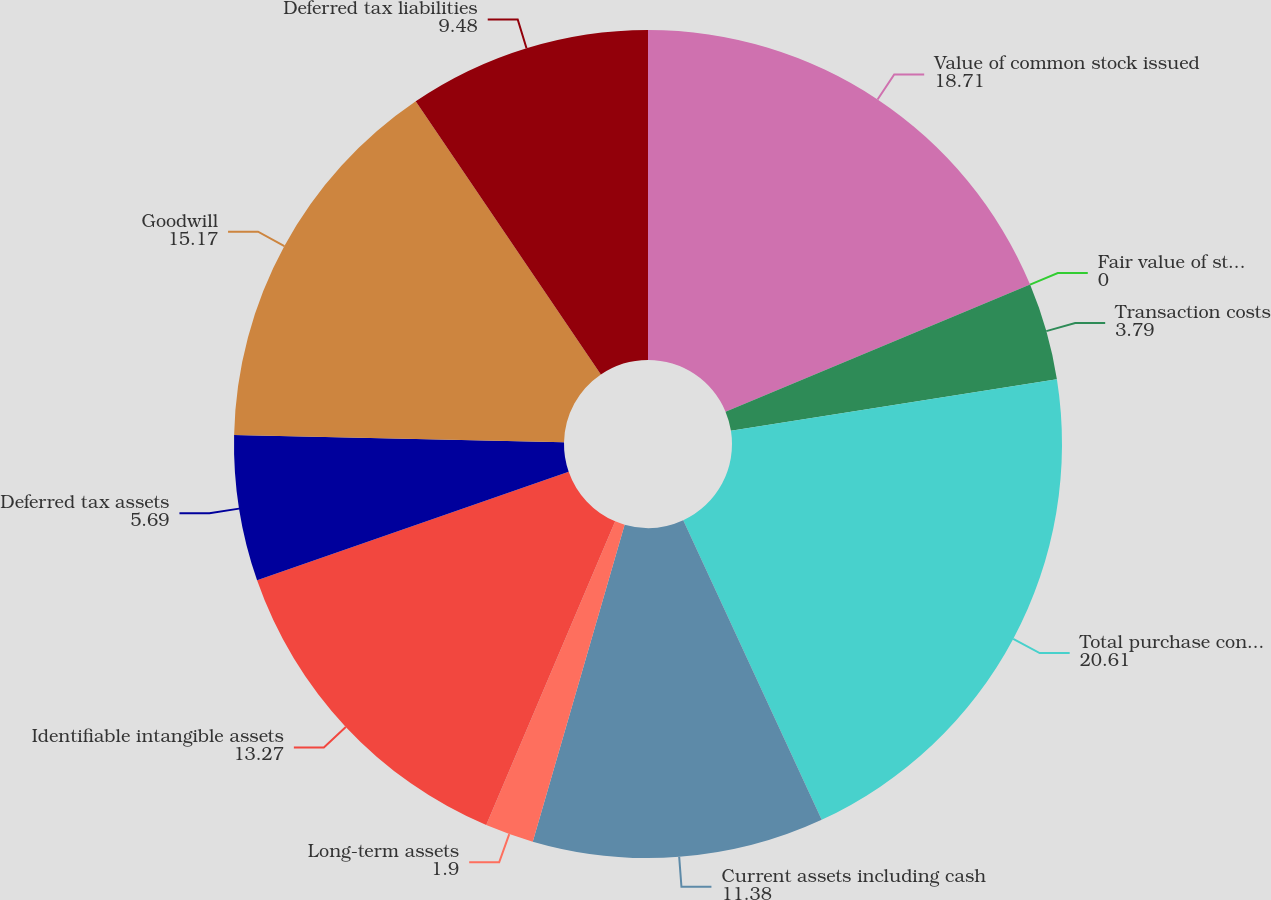Convert chart to OTSL. <chart><loc_0><loc_0><loc_500><loc_500><pie_chart><fcel>Value of common stock issued<fcel>Fair value of stock options<fcel>Transaction costs<fcel>Total purchase consideration<fcel>Current assets including cash<fcel>Long-term assets<fcel>Identifiable intangible assets<fcel>Deferred tax assets<fcel>Goodwill<fcel>Deferred tax liabilities<nl><fcel>18.71%<fcel>0.0%<fcel>3.79%<fcel>20.61%<fcel>11.38%<fcel>1.9%<fcel>13.27%<fcel>5.69%<fcel>15.17%<fcel>9.48%<nl></chart> 